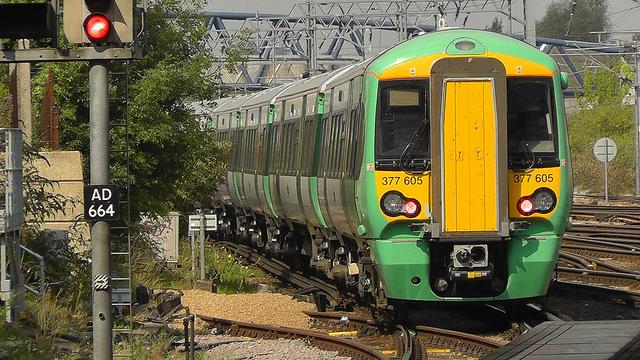What color is the light?
Short answer required. Red. What is the train for?
Give a very brief answer. Transportation. What vehicle is this?
Be succinct. Train. 